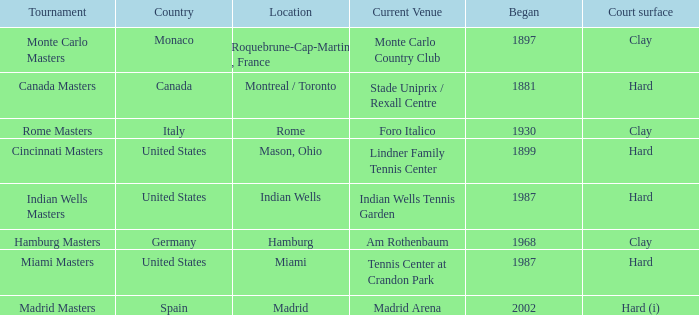What year was the tournament first held in Italy? 1930.0. 